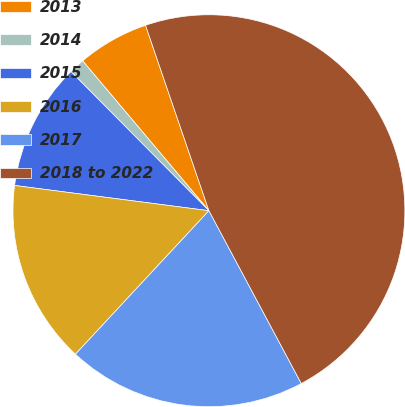Convert chart to OTSL. <chart><loc_0><loc_0><loc_500><loc_500><pie_chart><fcel>2013<fcel>2014<fcel>2015<fcel>2016<fcel>2017<fcel>2018 to 2022<nl><fcel>5.9%<fcel>1.29%<fcel>10.51%<fcel>15.13%<fcel>19.74%<fcel>47.43%<nl></chart> 